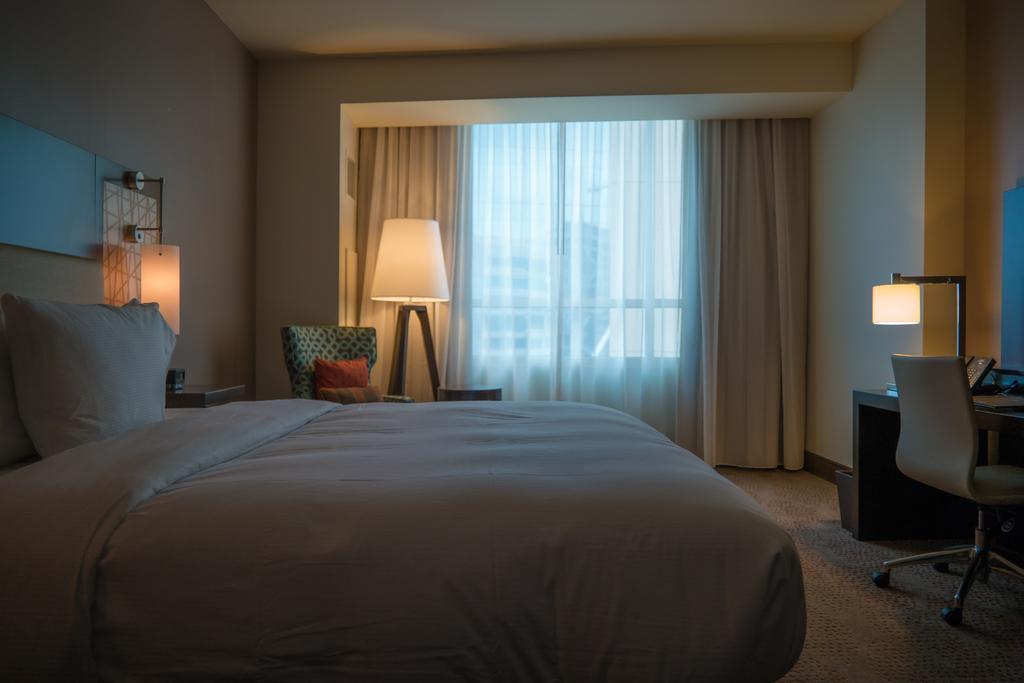Describe this image in one or two sentences. This is an inside picture of the room, we can see the bed, pillows, lamps, chairs, curtains and a table with some objects on it, also we can see the wall. 